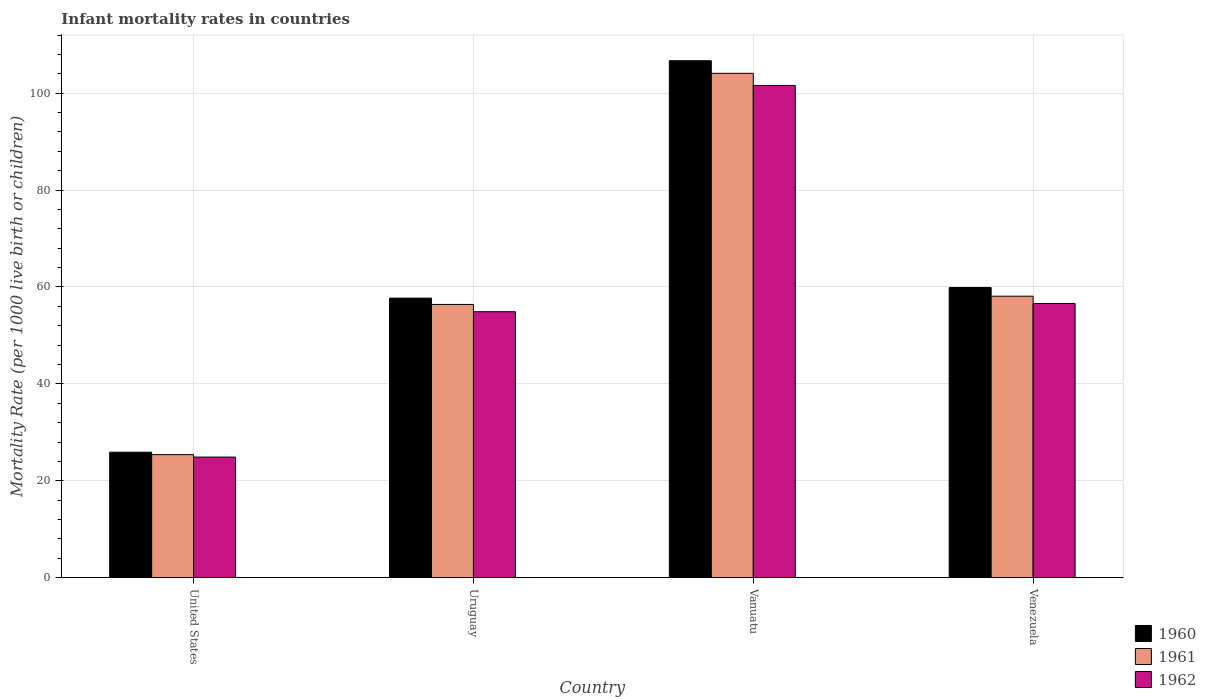How many different coloured bars are there?
Your answer should be very brief. 3. Are the number of bars per tick equal to the number of legend labels?
Provide a succinct answer. Yes. How many bars are there on the 2nd tick from the right?
Provide a short and direct response. 3. What is the label of the 2nd group of bars from the left?
Your answer should be compact. Uruguay. In how many cases, is the number of bars for a given country not equal to the number of legend labels?
Provide a short and direct response. 0. What is the infant mortality rate in 1960 in Vanuatu?
Make the answer very short. 106.7. Across all countries, what is the maximum infant mortality rate in 1961?
Offer a very short reply. 104.1. Across all countries, what is the minimum infant mortality rate in 1960?
Provide a succinct answer. 25.9. In which country was the infant mortality rate in 1960 maximum?
Offer a very short reply. Vanuatu. In which country was the infant mortality rate in 1962 minimum?
Offer a terse response. United States. What is the total infant mortality rate in 1961 in the graph?
Ensure brevity in your answer.  244. What is the difference between the infant mortality rate in 1961 in Uruguay and that in Vanuatu?
Provide a short and direct response. -47.7. What is the difference between the infant mortality rate in 1962 in Venezuela and the infant mortality rate in 1960 in Uruguay?
Make the answer very short. -1.1. What is the average infant mortality rate in 1961 per country?
Provide a succinct answer. 61. What is the difference between the infant mortality rate of/in 1960 and infant mortality rate of/in 1961 in Venezuela?
Provide a succinct answer. 1.8. What is the ratio of the infant mortality rate in 1962 in United States to that in Vanuatu?
Ensure brevity in your answer.  0.25. Is the difference between the infant mortality rate in 1960 in United States and Venezuela greater than the difference between the infant mortality rate in 1961 in United States and Venezuela?
Provide a short and direct response. No. What is the difference between the highest and the second highest infant mortality rate in 1962?
Keep it short and to the point. -45. What is the difference between the highest and the lowest infant mortality rate in 1962?
Your answer should be very brief. 76.7. Is the sum of the infant mortality rate in 1961 in United States and Uruguay greater than the maximum infant mortality rate in 1962 across all countries?
Give a very brief answer. No. What does the 2nd bar from the left in Uruguay represents?
Provide a short and direct response. 1961. Is it the case that in every country, the sum of the infant mortality rate in 1962 and infant mortality rate in 1961 is greater than the infant mortality rate in 1960?
Offer a very short reply. Yes. How many bars are there?
Your answer should be very brief. 12. Are all the bars in the graph horizontal?
Give a very brief answer. No. How many countries are there in the graph?
Your answer should be compact. 4. What is the difference between two consecutive major ticks on the Y-axis?
Ensure brevity in your answer.  20. How many legend labels are there?
Keep it short and to the point. 3. How are the legend labels stacked?
Offer a terse response. Vertical. What is the title of the graph?
Offer a very short reply. Infant mortality rates in countries. Does "1986" appear as one of the legend labels in the graph?
Provide a succinct answer. No. What is the label or title of the Y-axis?
Ensure brevity in your answer.  Mortality Rate (per 1000 live birth or children). What is the Mortality Rate (per 1000 live birth or children) in 1960 in United States?
Give a very brief answer. 25.9. What is the Mortality Rate (per 1000 live birth or children) in 1961 in United States?
Ensure brevity in your answer.  25.4. What is the Mortality Rate (per 1000 live birth or children) of 1962 in United States?
Provide a short and direct response. 24.9. What is the Mortality Rate (per 1000 live birth or children) in 1960 in Uruguay?
Ensure brevity in your answer.  57.7. What is the Mortality Rate (per 1000 live birth or children) in 1961 in Uruguay?
Offer a very short reply. 56.4. What is the Mortality Rate (per 1000 live birth or children) in 1962 in Uruguay?
Ensure brevity in your answer.  54.9. What is the Mortality Rate (per 1000 live birth or children) of 1960 in Vanuatu?
Offer a terse response. 106.7. What is the Mortality Rate (per 1000 live birth or children) of 1961 in Vanuatu?
Provide a succinct answer. 104.1. What is the Mortality Rate (per 1000 live birth or children) of 1962 in Vanuatu?
Provide a short and direct response. 101.6. What is the Mortality Rate (per 1000 live birth or children) of 1960 in Venezuela?
Your answer should be very brief. 59.9. What is the Mortality Rate (per 1000 live birth or children) of 1961 in Venezuela?
Ensure brevity in your answer.  58.1. What is the Mortality Rate (per 1000 live birth or children) in 1962 in Venezuela?
Offer a terse response. 56.6. Across all countries, what is the maximum Mortality Rate (per 1000 live birth or children) in 1960?
Offer a very short reply. 106.7. Across all countries, what is the maximum Mortality Rate (per 1000 live birth or children) of 1961?
Your response must be concise. 104.1. Across all countries, what is the maximum Mortality Rate (per 1000 live birth or children) of 1962?
Offer a terse response. 101.6. Across all countries, what is the minimum Mortality Rate (per 1000 live birth or children) in 1960?
Keep it short and to the point. 25.9. Across all countries, what is the minimum Mortality Rate (per 1000 live birth or children) of 1961?
Make the answer very short. 25.4. Across all countries, what is the minimum Mortality Rate (per 1000 live birth or children) of 1962?
Offer a terse response. 24.9. What is the total Mortality Rate (per 1000 live birth or children) in 1960 in the graph?
Offer a very short reply. 250.2. What is the total Mortality Rate (per 1000 live birth or children) of 1961 in the graph?
Make the answer very short. 244. What is the total Mortality Rate (per 1000 live birth or children) of 1962 in the graph?
Your answer should be very brief. 238. What is the difference between the Mortality Rate (per 1000 live birth or children) of 1960 in United States and that in Uruguay?
Ensure brevity in your answer.  -31.8. What is the difference between the Mortality Rate (per 1000 live birth or children) of 1961 in United States and that in Uruguay?
Keep it short and to the point. -31. What is the difference between the Mortality Rate (per 1000 live birth or children) of 1962 in United States and that in Uruguay?
Provide a succinct answer. -30. What is the difference between the Mortality Rate (per 1000 live birth or children) in 1960 in United States and that in Vanuatu?
Provide a short and direct response. -80.8. What is the difference between the Mortality Rate (per 1000 live birth or children) of 1961 in United States and that in Vanuatu?
Offer a very short reply. -78.7. What is the difference between the Mortality Rate (per 1000 live birth or children) of 1962 in United States and that in Vanuatu?
Give a very brief answer. -76.7. What is the difference between the Mortality Rate (per 1000 live birth or children) of 1960 in United States and that in Venezuela?
Make the answer very short. -34. What is the difference between the Mortality Rate (per 1000 live birth or children) of 1961 in United States and that in Venezuela?
Provide a succinct answer. -32.7. What is the difference between the Mortality Rate (per 1000 live birth or children) of 1962 in United States and that in Venezuela?
Your answer should be compact. -31.7. What is the difference between the Mortality Rate (per 1000 live birth or children) of 1960 in Uruguay and that in Vanuatu?
Provide a succinct answer. -49. What is the difference between the Mortality Rate (per 1000 live birth or children) in 1961 in Uruguay and that in Vanuatu?
Offer a terse response. -47.7. What is the difference between the Mortality Rate (per 1000 live birth or children) in 1962 in Uruguay and that in Vanuatu?
Your response must be concise. -46.7. What is the difference between the Mortality Rate (per 1000 live birth or children) of 1960 in Uruguay and that in Venezuela?
Offer a very short reply. -2.2. What is the difference between the Mortality Rate (per 1000 live birth or children) in 1961 in Uruguay and that in Venezuela?
Make the answer very short. -1.7. What is the difference between the Mortality Rate (per 1000 live birth or children) in 1962 in Uruguay and that in Venezuela?
Keep it short and to the point. -1.7. What is the difference between the Mortality Rate (per 1000 live birth or children) in 1960 in Vanuatu and that in Venezuela?
Your response must be concise. 46.8. What is the difference between the Mortality Rate (per 1000 live birth or children) in 1960 in United States and the Mortality Rate (per 1000 live birth or children) in 1961 in Uruguay?
Make the answer very short. -30.5. What is the difference between the Mortality Rate (per 1000 live birth or children) in 1960 in United States and the Mortality Rate (per 1000 live birth or children) in 1962 in Uruguay?
Your answer should be compact. -29. What is the difference between the Mortality Rate (per 1000 live birth or children) in 1961 in United States and the Mortality Rate (per 1000 live birth or children) in 1962 in Uruguay?
Offer a terse response. -29.5. What is the difference between the Mortality Rate (per 1000 live birth or children) of 1960 in United States and the Mortality Rate (per 1000 live birth or children) of 1961 in Vanuatu?
Make the answer very short. -78.2. What is the difference between the Mortality Rate (per 1000 live birth or children) of 1960 in United States and the Mortality Rate (per 1000 live birth or children) of 1962 in Vanuatu?
Give a very brief answer. -75.7. What is the difference between the Mortality Rate (per 1000 live birth or children) of 1961 in United States and the Mortality Rate (per 1000 live birth or children) of 1962 in Vanuatu?
Your answer should be compact. -76.2. What is the difference between the Mortality Rate (per 1000 live birth or children) in 1960 in United States and the Mortality Rate (per 1000 live birth or children) in 1961 in Venezuela?
Ensure brevity in your answer.  -32.2. What is the difference between the Mortality Rate (per 1000 live birth or children) in 1960 in United States and the Mortality Rate (per 1000 live birth or children) in 1962 in Venezuela?
Provide a short and direct response. -30.7. What is the difference between the Mortality Rate (per 1000 live birth or children) of 1961 in United States and the Mortality Rate (per 1000 live birth or children) of 1962 in Venezuela?
Your answer should be compact. -31.2. What is the difference between the Mortality Rate (per 1000 live birth or children) of 1960 in Uruguay and the Mortality Rate (per 1000 live birth or children) of 1961 in Vanuatu?
Your answer should be compact. -46.4. What is the difference between the Mortality Rate (per 1000 live birth or children) of 1960 in Uruguay and the Mortality Rate (per 1000 live birth or children) of 1962 in Vanuatu?
Your answer should be very brief. -43.9. What is the difference between the Mortality Rate (per 1000 live birth or children) in 1961 in Uruguay and the Mortality Rate (per 1000 live birth or children) in 1962 in Vanuatu?
Your response must be concise. -45.2. What is the difference between the Mortality Rate (per 1000 live birth or children) in 1960 in Uruguay and the Mortality Rate (per 1000 live birth or children) in 1961 in Venezuela?
Keep it short and to the point. -0.4. What is the difference between the Mortality Rate (per 1000 live birth or children) in 1960 in Uruguay and the Mortality Rate (per 1000 live birth or children) in 1962 in Venezuela?
Provide a short and direct response. 1.1. What is the difference between the Mortality Rate (per 1000 live birth or children) in 1960 in Vanuatu and the Mortality Rate (per 1000 live birth or children) in 1961 in Venezuela?
Your response must be concise. 48.6. What is the difference between the Mortality Rate (per 1000 live birth or children) in 1960 in Vanuatu and the Mortality Rate (per 1000 live birth or children) in 1962 in Venezuela?
Your answer should be compact. 50.1. What is the difference between the Mortality Rate (per 1000 live birth or children) of 1961 in Vanuatu and the Mortality Rate (per 1000 live birth or children) of 1962 in Venezuela?
Offer a very short reply. 47.5. What is the average Mortality Rate (per 1000 live birth or children) in 1960 per country?
Offer a very short reply. 62.55. What is the average Mortality Rate (per 1000 live birth or children) of 1961 per country?
Provide a succinct answer. 61. What is the average Mortality Rate (per 1000 live birth or children) of 1962 per country?
Give a very brief answer. 59.5. What is the difference between the Mortality Rate (per 1000 live birth or children) of 1960 and Mortality Rate (per 1000 live birth or children) of 1961 in United States?
Your answer should be very brief. 0.5. What is the difference between the Mortality Rate (per 1000 live birth or children) in 1960 and Mortality Rate (per 1000 live birth or children) in 1962 in United States?
Offer a terse response. 1. What is the difference between the Mortality Rate (per 1000 live birth or children) in 1961 and Mortality Rate (per 1000 live birth or children) in 1962 in United States?
Your response must be concise. 0.5. What is the difference between the Mortality Rate (per 1000 live birth or children) in 1960 and Mortality Rate (per 1000 live birth or children) in 1962 in Uruguay?
Offer a terse response. 2.8. What is the difference between the Mortality Rate (per 1000 live birth or children) in 1961 and Mortality Rate (per 1000 live birth or children) in 1962 in Vanuatu?
Your answer should be very brief. 2.5. What is the ratio of the Mortality Rate (per 1000 live birth or children) of 1960 in United States to that in Uruguay?
Provide a succinct answer. 0.45. What is the ratio of the Mortality Rate (per 1000 live birth or children) of 1961 in United States to that in Uruguay?
Your answer should be compact. 0.45. What is the ratio of the Mortality Rate (per 1000 live birth or children) in 1962 in United States to that in Uruguay?
Provide a short and direct response. 0.45. What is the ratio of the Mortality Rate (per 1000 live birth or children) of 1960 in United States to that in Vanuatu?
Offer a very short reply. 0.24. What is the ratio of the Mortality Rate (per 1000 live birth or children) in 1961 in United States to that in Vanuatu?
Keep it short and to the point. 0.24. What is the ratio of the Mortality Rate (per 1000 live birth or children) of 1962 in United States to that in Vanuatu?
Your answer should be compact. 0.25. What is the ratio of the Mortality Rate (per 1000 live birth or children) of 1960 in United States to that in Venezuela?
Your response must be concise. 0.43. What is the ratio of the Mortality Rate (per 1000 live birth or children) in 1961 in United States to that in Venezuela?
Your response must be concise. 0.44. What is the ratio of the Mortality Rate (per 1000 live birth or children) of 1962 in United States to that in Venezuela?
Your answer should be very brief. 0.44. What is the ratio of the Mortality Rate (per 1000 live birth or children) in 1960 in Uruguay to that in Vanuatu?
Your response must be concise. 0.54. What is the ratio of the Mortality Rate (per 1000 live birth or children) of 1961 in Uruguay to that in Vanuatu?
Ensure brevity in your answer.  0.54. What is the ratio of the Mortality Rate (per 1000 live birth or children) in 1962 in Uruguay to that in Vanuatu?
Your answer should be compact. 0.54. What is the ratio of the Mortality Rate (per 1000 live birth or children) in 1960 in Uruguay to that in Venezuela?
Offer a terse response. 0.96. What is the ratio of the Mortality Rate (per 1000 live birth or children) of 1961 in Uruguay to that in Venezuela?
Keep it short and to the point. 0.97. What is the ratio of the Mortality Rate (per 1000 live birth or children) of 1962 in Uruguay to that in Venezuela?
Ensure brevity in your answer.  0.97. What is the ratio of the Mortality Rate (per 1000 live birth or children) of 1960 in Vanuatu to that in Venezuela?
Keep it short and to the point. 1.78. What is the ratio of the Mortality Rate (per 1000 live birth or children) in 1961 in Vanuatu to that in Venezuela?
Provide a succinct answer. 1.79. What is the ratio of the Mortality Rate (per 1000 live birth or children) in 1962 in Vanuatu to that in Venezuela?
Keep it short and to the point. 1.8. What is the difference between the highest and the second highest Mortality Rate (per 1000 live birth or children) of 1960?
Your answer should be very brief. 46.8. What is the difference between the highest and the second highest Mortality Rate (per 1000 live birth or children) in 1962?
Keep it short and to the point. 45. What is the difference between the highest and the lowest Mortality Rate (per 1000 live birth or children) of 1960?
Keep it short and to the point. 80.8. What is the difference between the highest and the lowest Mortality Rate (per 1000 live birth or children) of 1961?
Offer a very short reply. 78.7. What is the difference between the highest and the lowest Mortality Rate (per 1000 live birth or children) in 1962?
Your response must be concise. 76.7. 